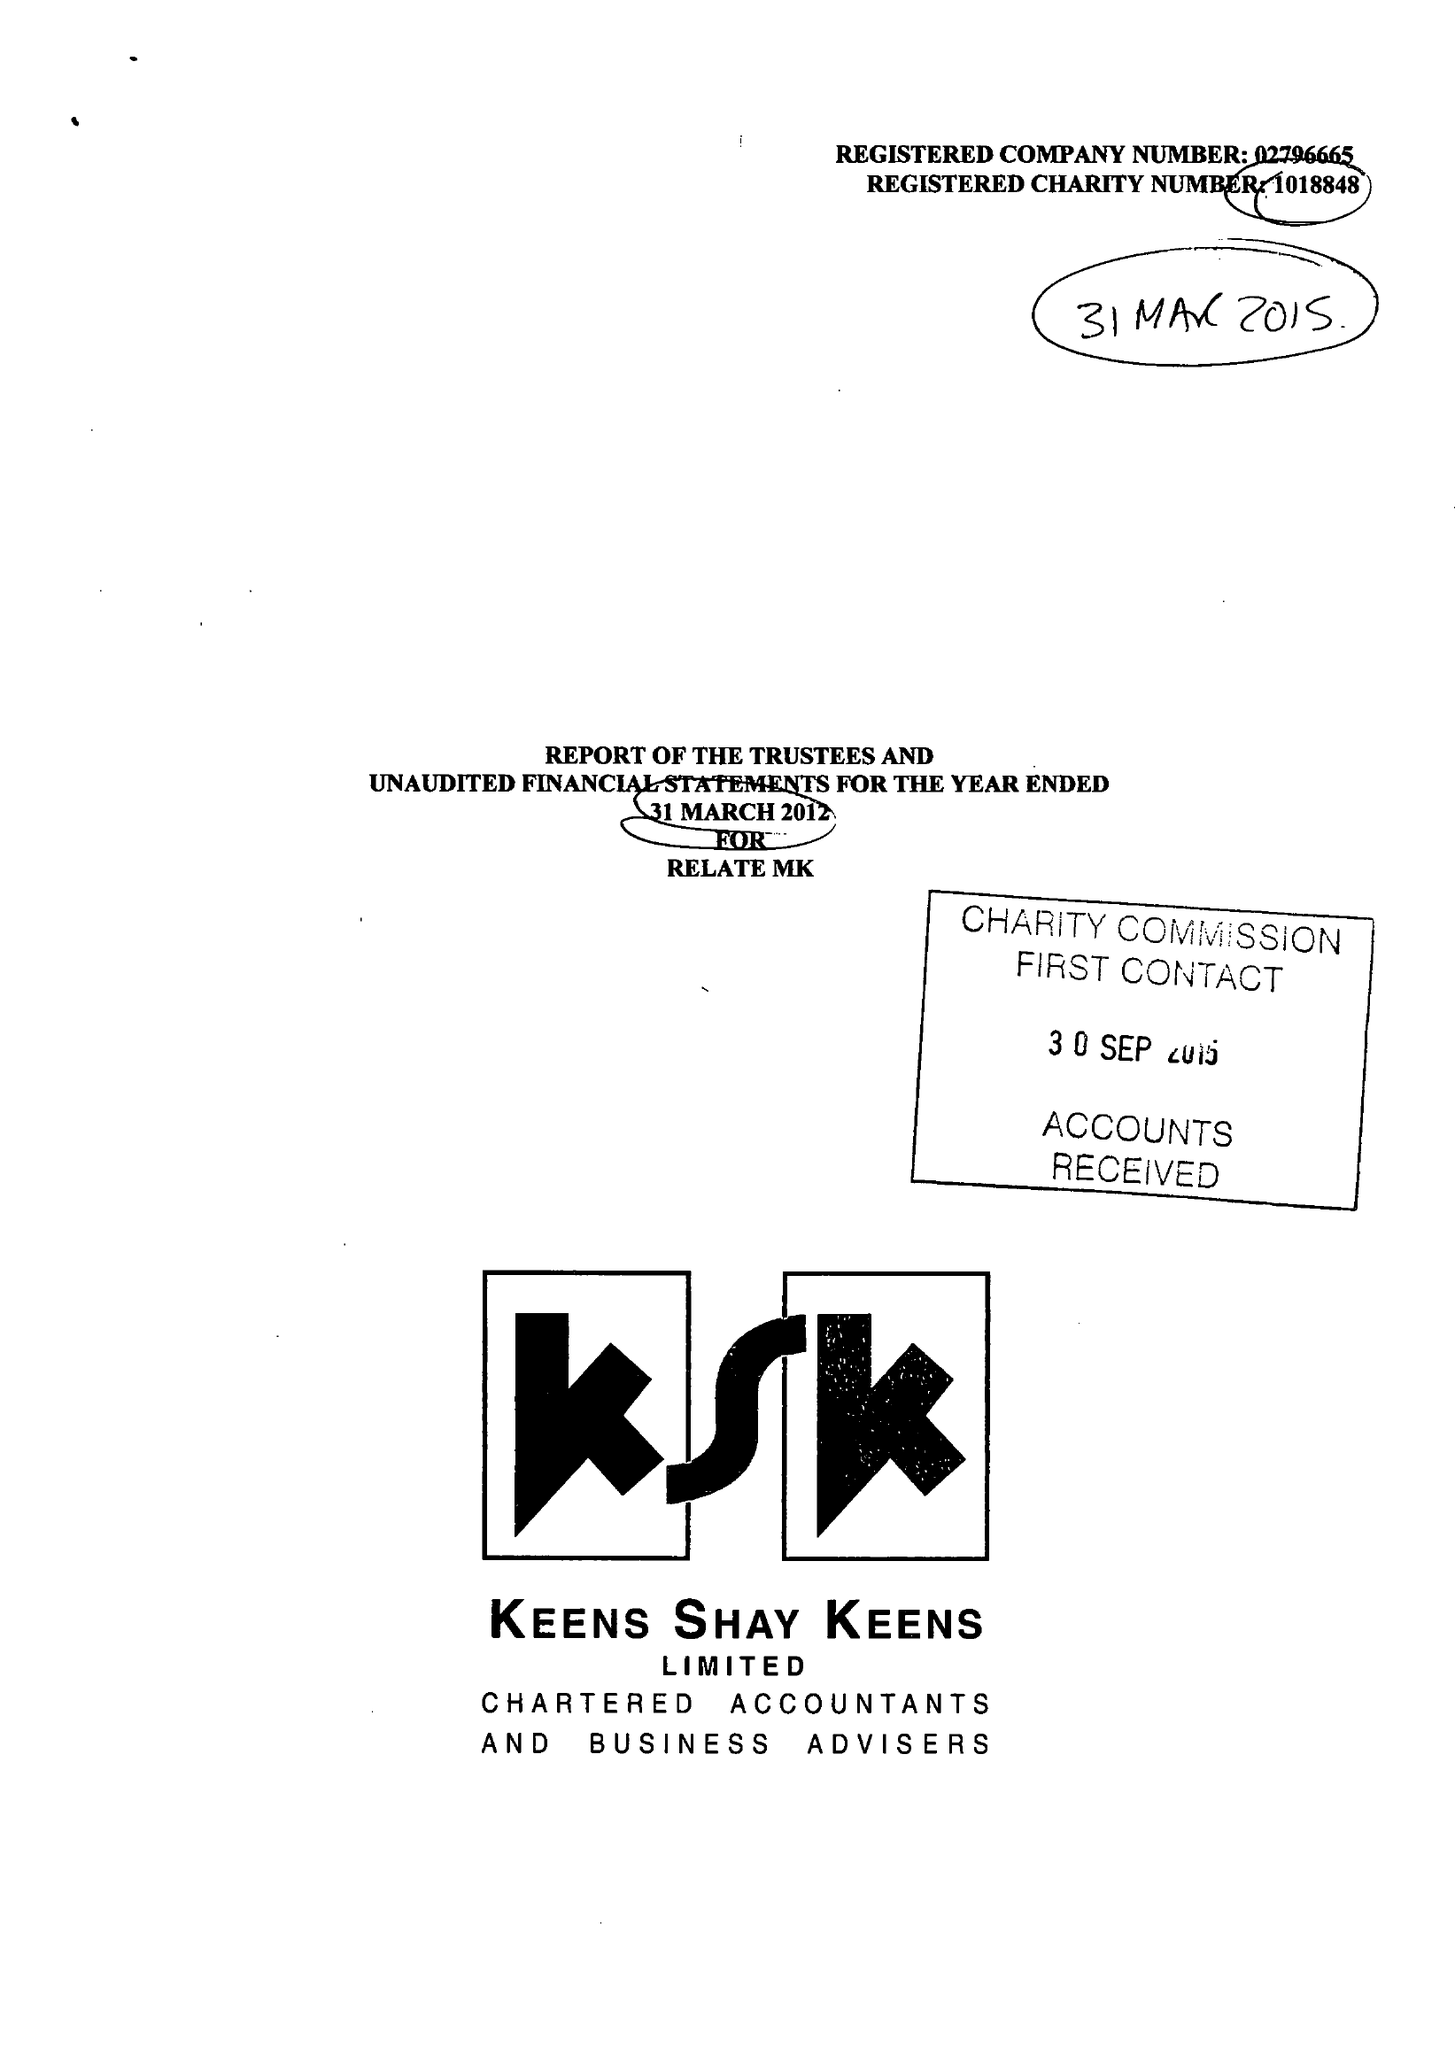What is the value for the charity_name?
Answer the question using a single word or phrase. Relate (Milton Keynes) 